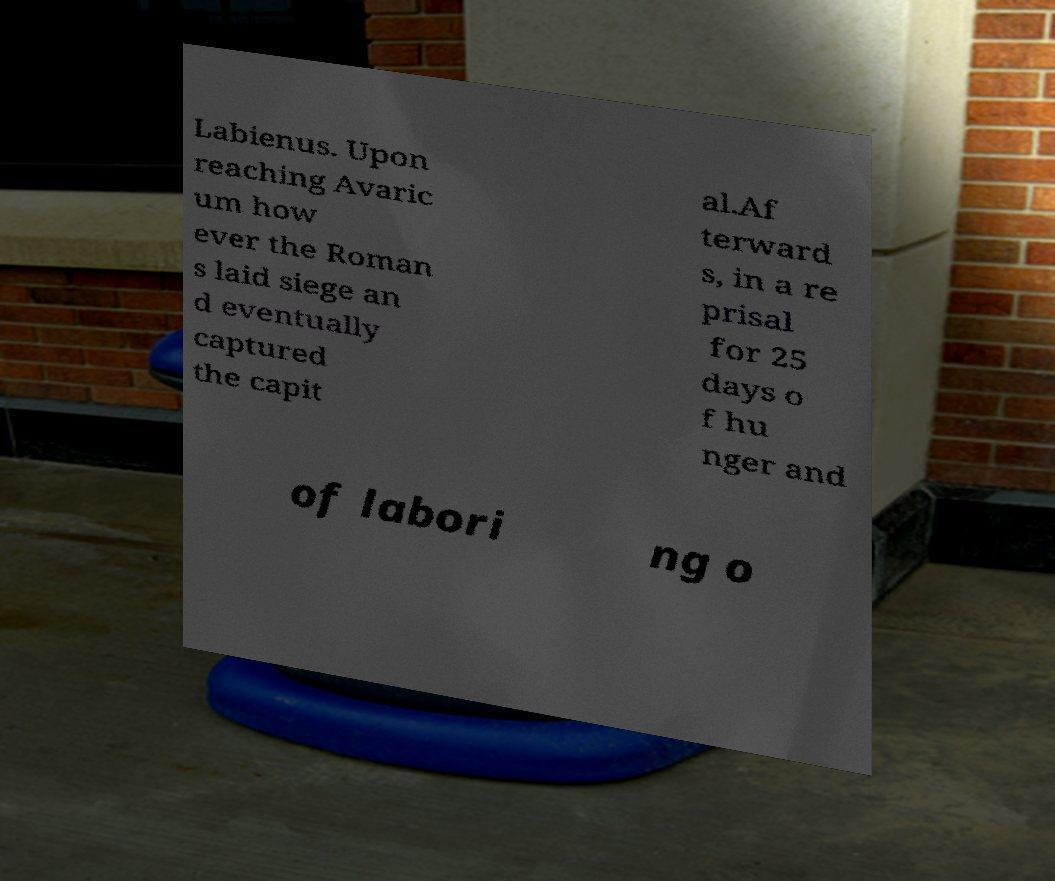Please read and relay the text visible in this image. What does it say? Labienus. Upon reaching Avaric um how ever the Roman s laid siege an d eventually captured the capit al.Af terward s, in a re prisal for 25 days o f hu nger and of labori ng o 